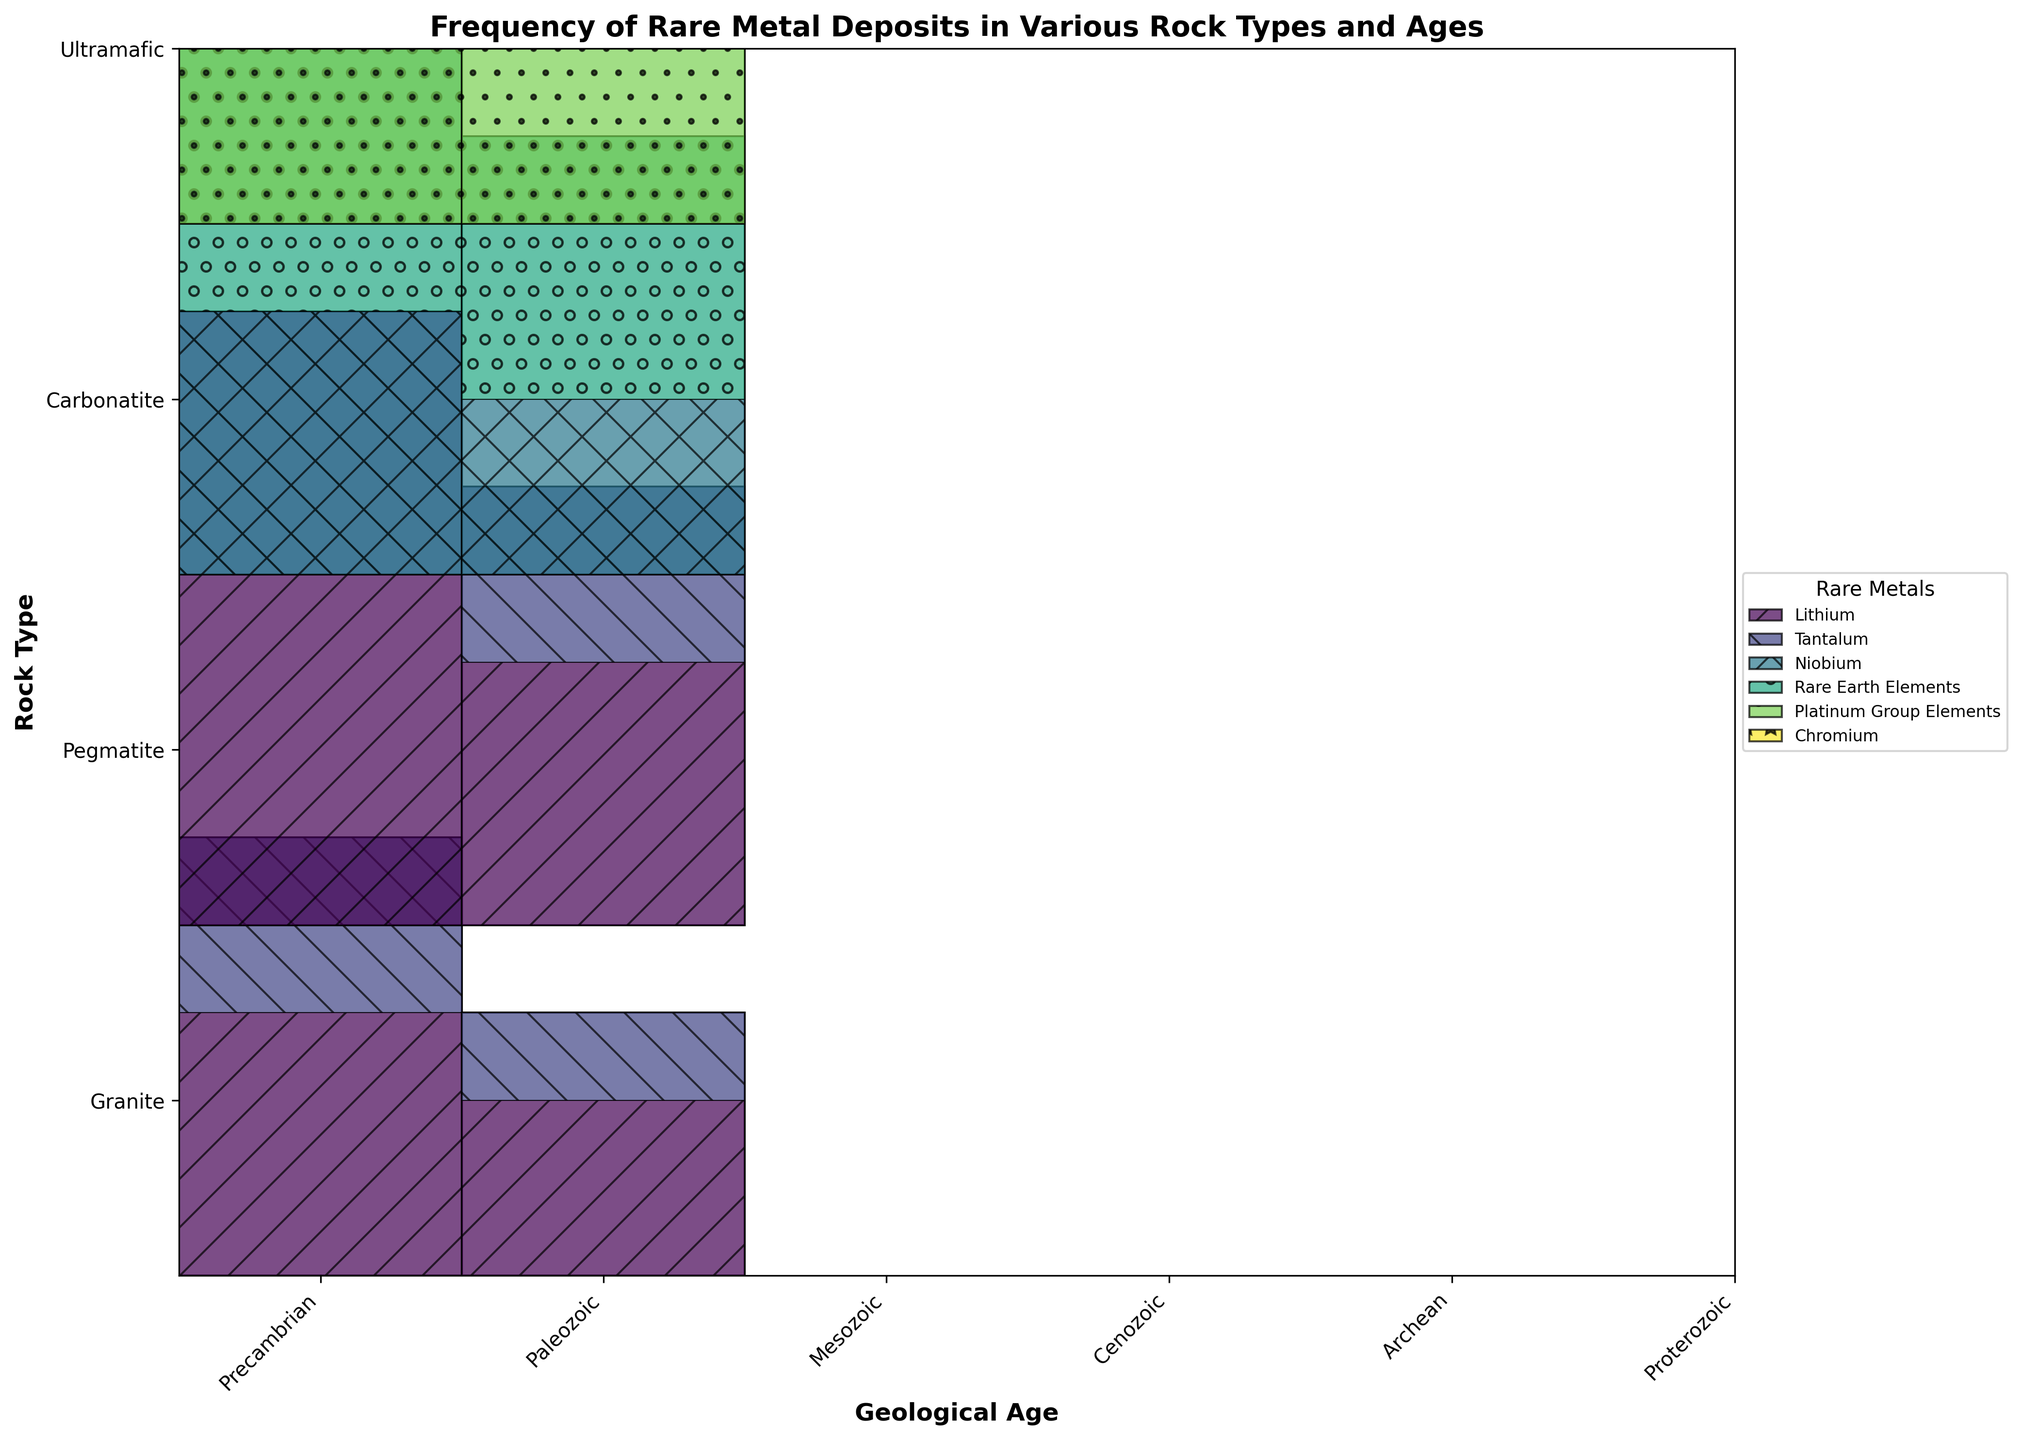What are the geological ages displayed on the x-axis? The x-axis labels represent different geological ages. From the mosaic plot, the ages can be identified based on their associated labels.
Answer: Precambrian, Paleozoic, Mesozoic, Cenozoic, Archean, Proterozoic Which rock type has the highest variety of rare metal deposits in the Precambrian age? To answer this, observe the segments for each rock type in the Precambrian age and count the different rare metals within the rectangles.
Answer: Pegmatite Is the frequency of Lithium deposits higher in Granite or Pegmatite during the Precambrian age? Examine the heights of the corresponding segments for Lithium in Granite and Pegmatite during the Precambrian age. Pegmatite has a 'Very High' frequency while Granite has 'High'.
Answer: Pegmatite Between Mesozoic and Cenozoic ages, which one has the higher combined frequency of Rare Earth Elements in Carbonatite? Add the frequency values of Rare Earth Elements for each age group: 'Very High' (4) in Mesozoic and 'High' (3) in Cenozoic. Mesozoic has a combined frequency of 4 while Cenozoic has 3.
Answer: Mesozoic Compare the combined frequency of all rare metals in Ultramafic rocks during Archean and Proterozoic ages. Which age has the higher frequency? Sum the frequencies of all rare metals in Ultramafic for both Archean (Platinum Group Elements - High (3); Chromium - Very High (4)) which totals to 7, and Proterozoic (Platinum Group Elements - Medium (2); Chromium - High (3)) which totals to 5. Archean has a higher combined frequency.
Answer: Archean What is the rare metal with the lowest frequency in Granite during Paleozoic age and what is its frequency? Identify the segments for each metal in Granite during Paleozoic and check their frequency values. Tantalum has 'Low' frequency, which is the lowest.
Answer: Tantalum, Low By examining the colors and hatches, how many unique rare metals are represented in the plot? Count the legend entries, each corresponding to a unique rare metal.
Answer: 6 In terms of visual area, which rare metal is most abundant across all rock types and ages? Evaluate the size (area) of each rare metal segment across the entire plot. Rare Earth Elements in Carbonatite during Mesozoic has some of the largest segments, indicating abundance.
Answer: Rare Earth Elements How does the frequency of Chromium vary between Archean and Proterozoic ages in Ultramafic rocks? Look at Chromium segments in Ultramafic for both ages; 'Very High' (4) in Archean and 'High' (3) in Proterozoic. Compare that numerical representation.
Answer: Decreases from Very High to High What rock type and age combination has the lowest frequency of rare metal deposits overall? Identify the smallest total frequency segments amongst all rock type and age combinations; Granite during Paleozoic (Medium for Lithium and Low for Tantalum) totals to 3.
Answer: Granite, Paleozoic 